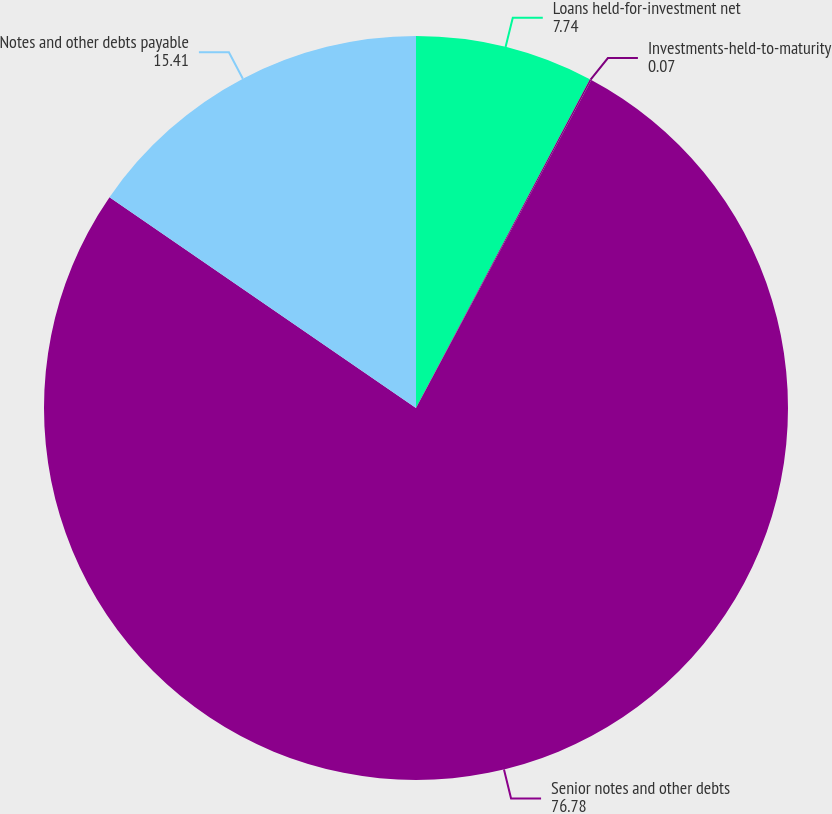Convert chart. <chart><loc_0><loc_0><loc_500><loc_500><pie_chart><fcel>Loans held-for-investment net<fcel>Investments-held-to-maturity<fcel>Senior notes and other debts<fcel>Notes and other debts payable<nl><fcel>7.74%<fcel>0.07%<fcel>76.78%<fcel>15.41%<nl></chart> 